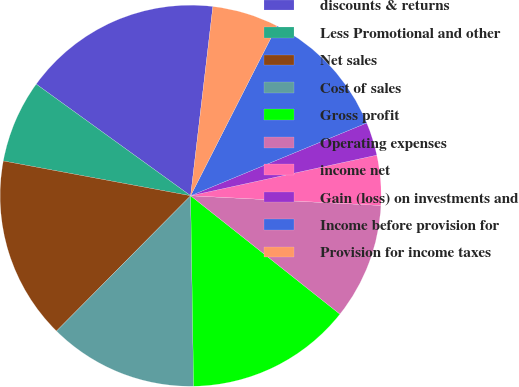Convert chart to OTSL. <chart><loc_0><loc_0><loc_500><loc_500><pie_chart><fcel>discounts & returns<fcel>Less Promotional and other<fcel>Net sales<fcel>Cost of sales<fcel>Gross profit<fcel>Operating expenses<fcel>income net<fcel>Gain (loss) on investments and<fcel>Income before provision for<fcel>Provision for income taxes<nl><fcel>16.9%<fcel>7.04%<fcel>15.49%<fcel>12.68%<fcel>14.08%<fcel>9.86%<fcel>4.23%<fcel>2.82%<fcel>11.27%<fcel>5.63%<nl></chart> 